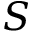<formula> <loc_0><loc_0><loc_500><loc_500>S</formula> 